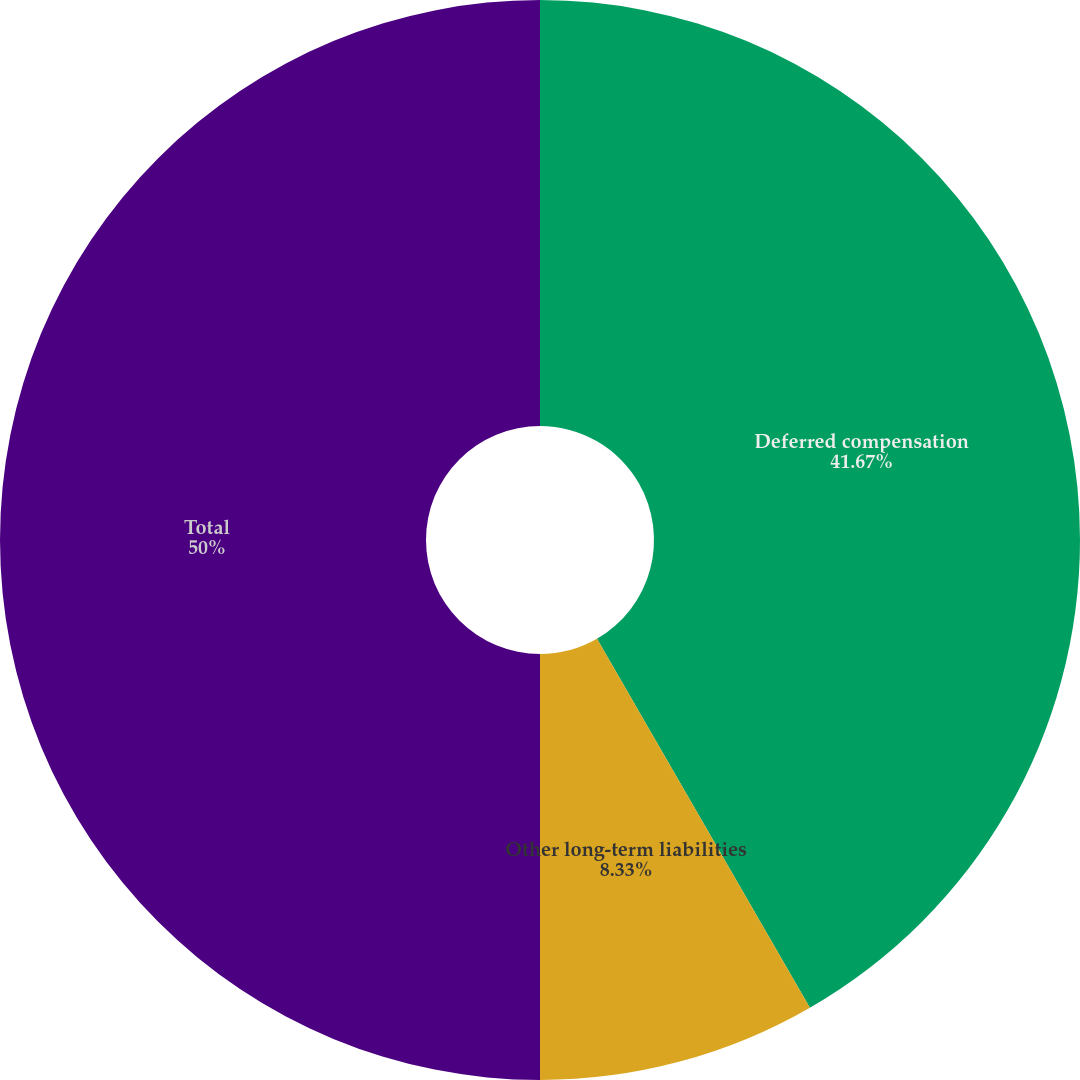Convert chart to OTSL. <chart><loc_0><loc_0><loc_500><loc_500><pie_chart><fcel>Deferred compensation<fcel>Other long-term liabilities<fcel>Total<nl><fcel>41.67%<fcel>8.33%<fcel>50.0%<nl></chart> 